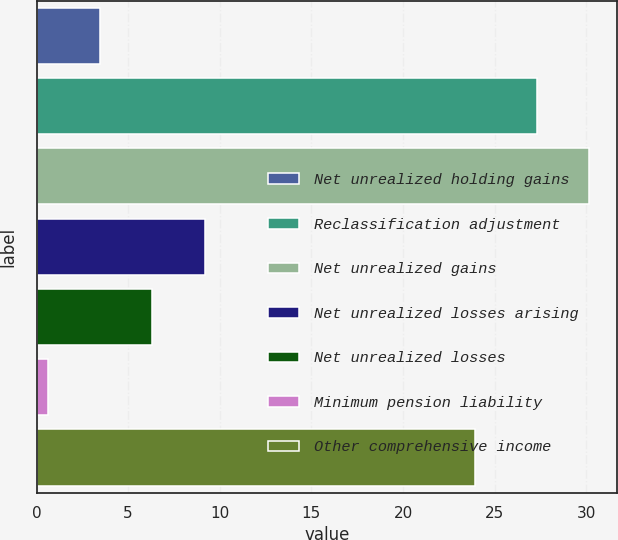Convert chart to OTSL. <chart><loc_0><loc_0><loc_500><loc_500><bar_chart><fcel>Net unrealized holding gains<fcel>Reclassification adjustment<fcel>Net unrealized gains<fcel>Net unrealized losses arising<fcel>Net unrealized losses<fcel>Minimum pension liability<fcel>Other comprehensive income<nl><fcel>3.46<fcel>27.3<fcel>30.16<fcel>9.18<fcel>6.32<fcel>0.6<fcel>23.9<nl></chart> 